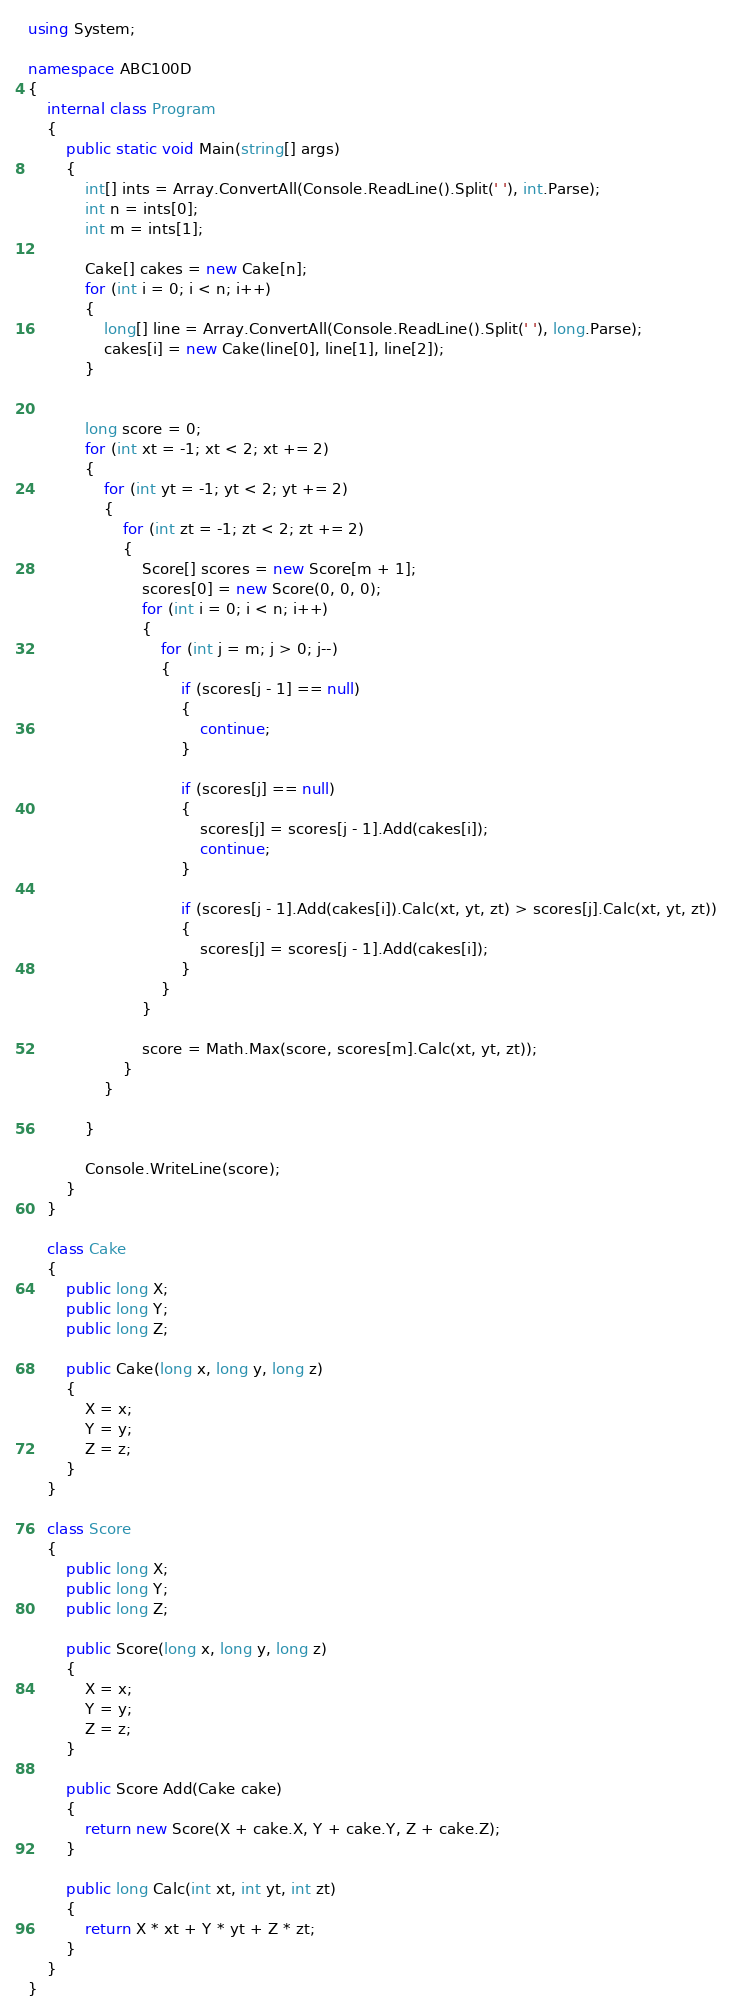<code> <loc_0><loc_0><loc_500><loc_500><_C#_>using System;

namespace ABC100D
{
    internal class Program
    {
        public static void Main(string[] args)
        {
            int[] ints = Array.ConvertAll(Console.ReadLine().Split(' '), int.Parse);
            int n = ints[0];
            int m = ints[1];

            Cake[] cakes = new Cake[n];
            for (int i = 0; i < n; i++)
            {
                long[] line = Array.ConvertAll(Console.ReadLine().Split(' '), long.Parse);
                cakes[i] = new Cake(line[0], line[1], line[2]);
            }


            long score = 0;
            for (int xt = -1; xt < 2; xt += 2)
            {
                for (int yt = -1; yt < 2; yt += 2)
                {
                    for (int zt = -1; zt < 2; zt += 2)
                    {
                        Score[] scores = new Score[m + 1];
                        scores[0] = new Score(0, 0, 0);
                        for (int i = 0; i < n; i++)
                        {
                            for (int j = m; j > 0; j--)
                            {
                                if (scores[j - 1] == null)
                                {
                                    continue;
                                }

                                if (scores[j] == null)
                                {
                                    scores[j] = scores[j - 1].Add(cakes[i]);
                                    continue;
                                }

                                if (scores[j - 1].Add(cakes[i]).Calc(xt, yt, zt) > scores[j].Calc(xt, yt, zt))
                                {
                                    scores[j] = scores[j - 1].Add(cakes[i]);
                                }
                            }
                        }
                        
                        score = Math.Max(score, scores[m].Calc(xt, yt, zt));
                    }
                }

            }

            Console.WriteLine(score);
        }
    }

    class Cake
    {
        public long X;
        public long Y;
        public long Z;

        public Cake(long x, long y, long z)
        {
            X = x;
            Y = y;
            Z = z;
        }
    }

    class Score
    {
        public long X;
        public long Y;
        public long Z;

        public Score(long x, long y, long z)
        {
            X = x;
            Y = y;
            Z = z;
        }

        public Score Add(Cake cake)
        {
            return new Score(X + cake.X, Y + cake.Y, Z + cake.Z);
        }

        public long Calc(int xt, int yt, int zt)
        {
            return X * xt + Y * yt + Z * zt;
        }
    }
}</code> 